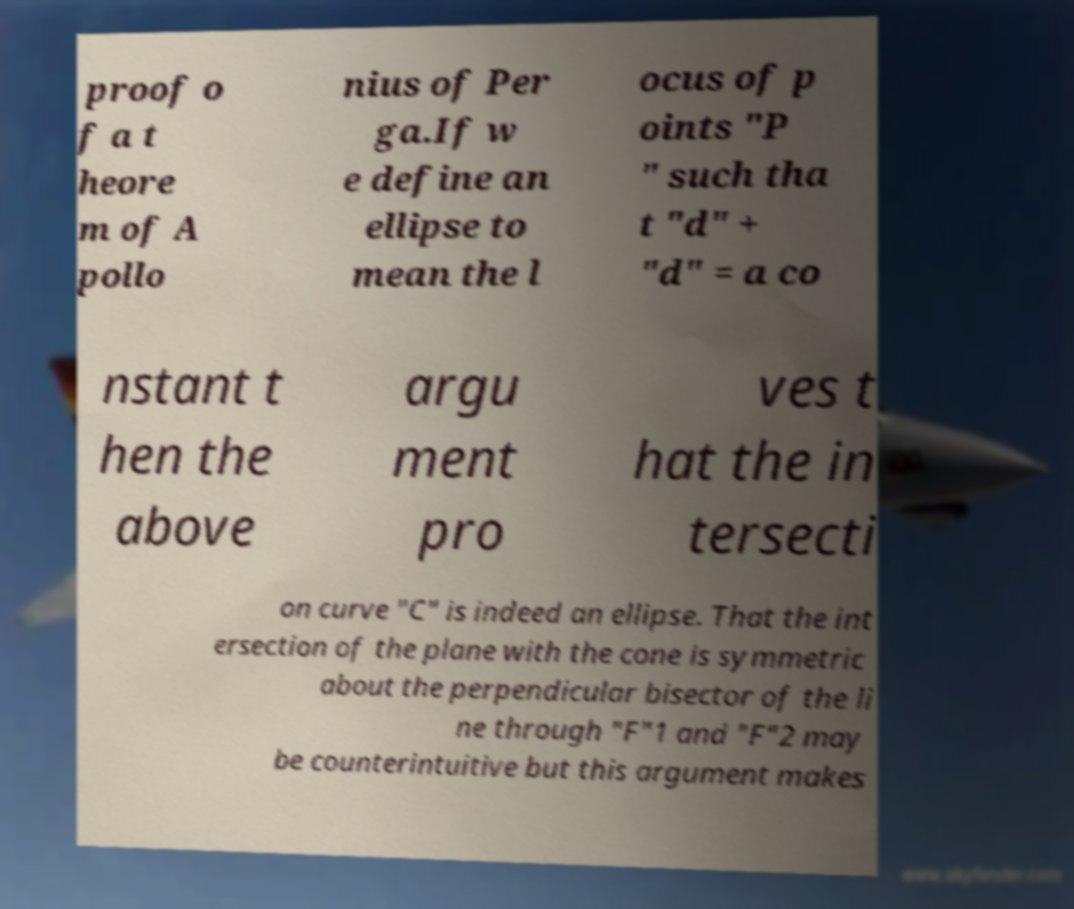I need the written content from this picture converted into text. Can you do that? proof o f a t heore m of A pollo nius of Per ga.If w e define an ellipse to mean the l ocus of p oints "P " such tha t "d" + "d" = a co nstant t hen the above argu ment pro ves t hat the in tersecti on curve "C" is indeed an ellipse. That the int ersection of the plane with the cone is symmetric about the perpendicular bisector of the li ne through "F"1 and "F"2 may be counterintuitive but this argument makes 